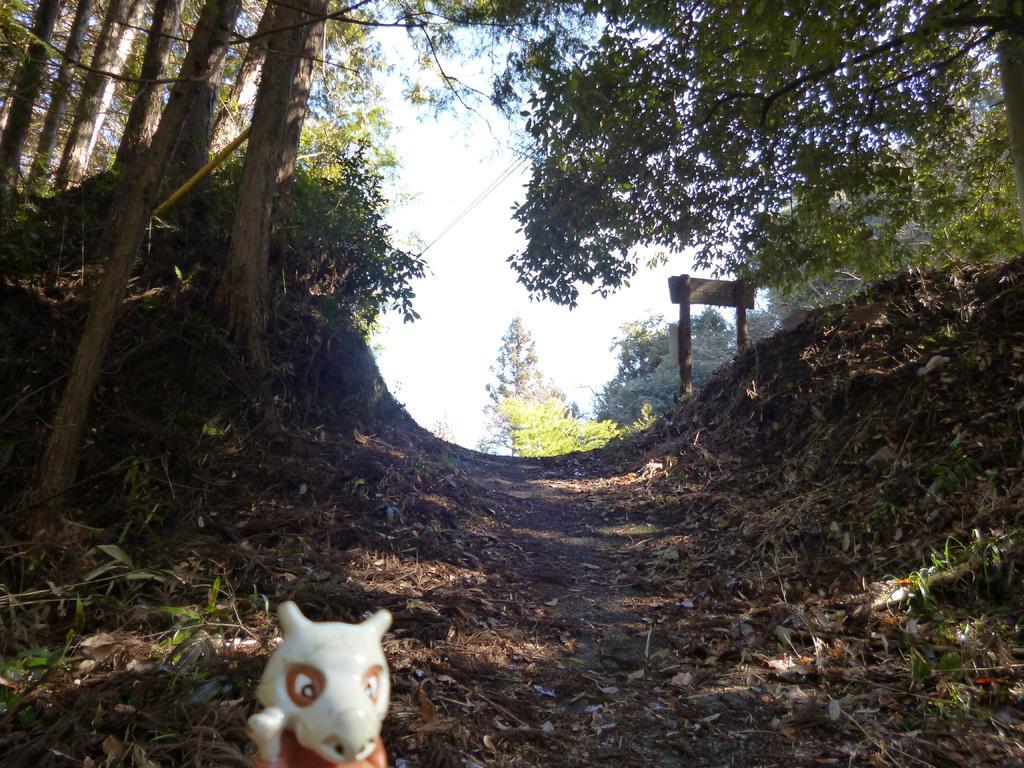Could you give a brief overview of what you see in this image? In this image I can see a toy on the road, beside that there are so many trees and board to the poles. 